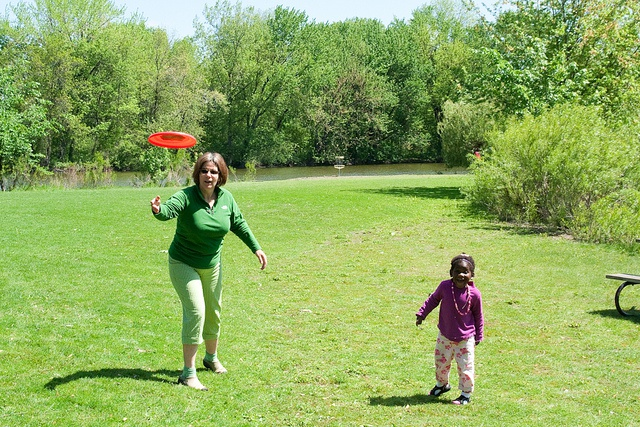Describe the objects in this image and their specific colors. I can see people in white, darkgreen, beige, lightgreen, and green tones, people in white, black, purple, and gray tones, frisbee in white, red, salmon, and olive tones, and bench in white, black, lightgray, gray, and darkgreen tones in this image. 